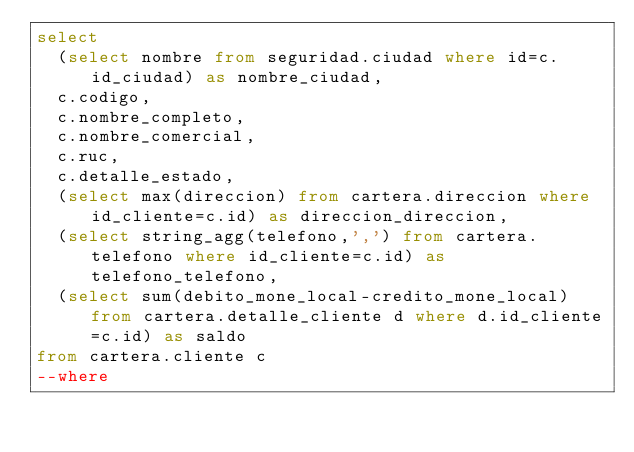<code> <loc_0><loc_0><loc_500><loc_500><_SQL_>select 
	(select nombre from seguridad.ciudad where id=c.id_ciudad) as nombre_ciudad,
	c.codigo,
	c.nombre_completo,
	c.nombre_comercial,
	c.ruc,
	c.detalle_estado,
	(select max(direccion) from cartera.direccion where id_cliente=c.id) as direccion_direccion,
	(select string_agg(telefono,',') from cartera.telefono where id_cliente=c.id) as telefono_telefono,
	(select sum(debito_mone_local-credito_mone_local) from cartera.detalle_cliente d where d.id_cliente=c.id) as saldo
from cartera.cliente c
--where</code> 